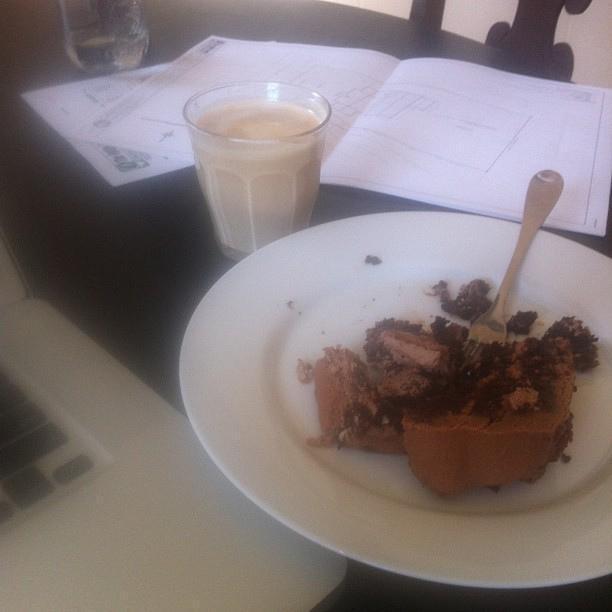How many forks are shown?
Give a very brief answer. 1. How many silverware are on the plate?
Give a very brief answer. 1. How many cups are in the picture?
Give a very brief answer. 2. How many slices of pizza are missing?
Give a very brief answer. 0. 